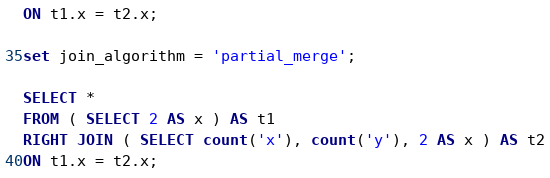Convert code to text. <code><loc_0><loc_0><loc_500><loc_500><_SQL_>ON t1.x = t2.x;

set join_algorithm = 'partial_merge';

SELECT *
FROM ( SELECT 2 AS x ) AS t1
RIGHT JOIN ( SELECT count('x'), count('y'), 2 AS x ) AS t2
ON t1.x = t2.x;
</code> 